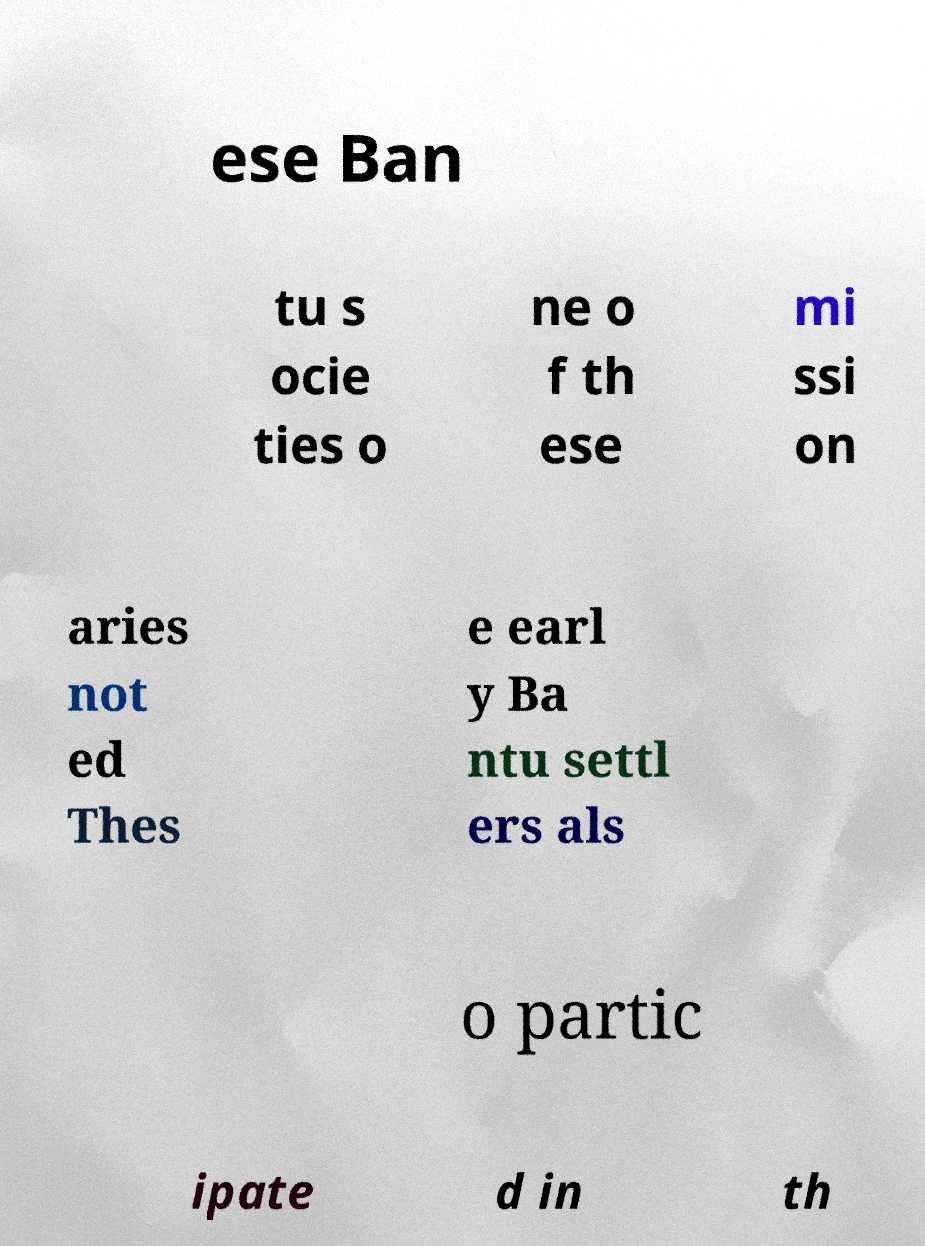Could you assist in decoding the text presented in this image and type it out clearly? ese Ban tu s ocie ties o ne o f th ese mi ssi on aries not ed Thes e earl y Ba ntu settl ers als o partic ipate d in th 